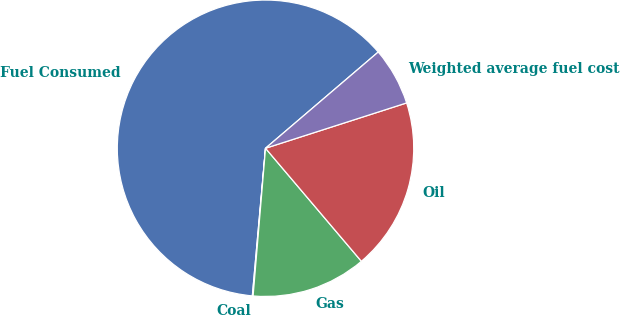<chart> <loc_0><loc_0><loc_500><loc_500><pie_chart><fcel>Fuel Consumed<fcel>Coal<fcel>Gas<fcel>Oil<fcel>Weighted average fuel cost<nl><fcel>62.33%<fcel>0.08%<fcel>12.53%<fcel>18.75%<fcel>6.3%<nl></chart> 